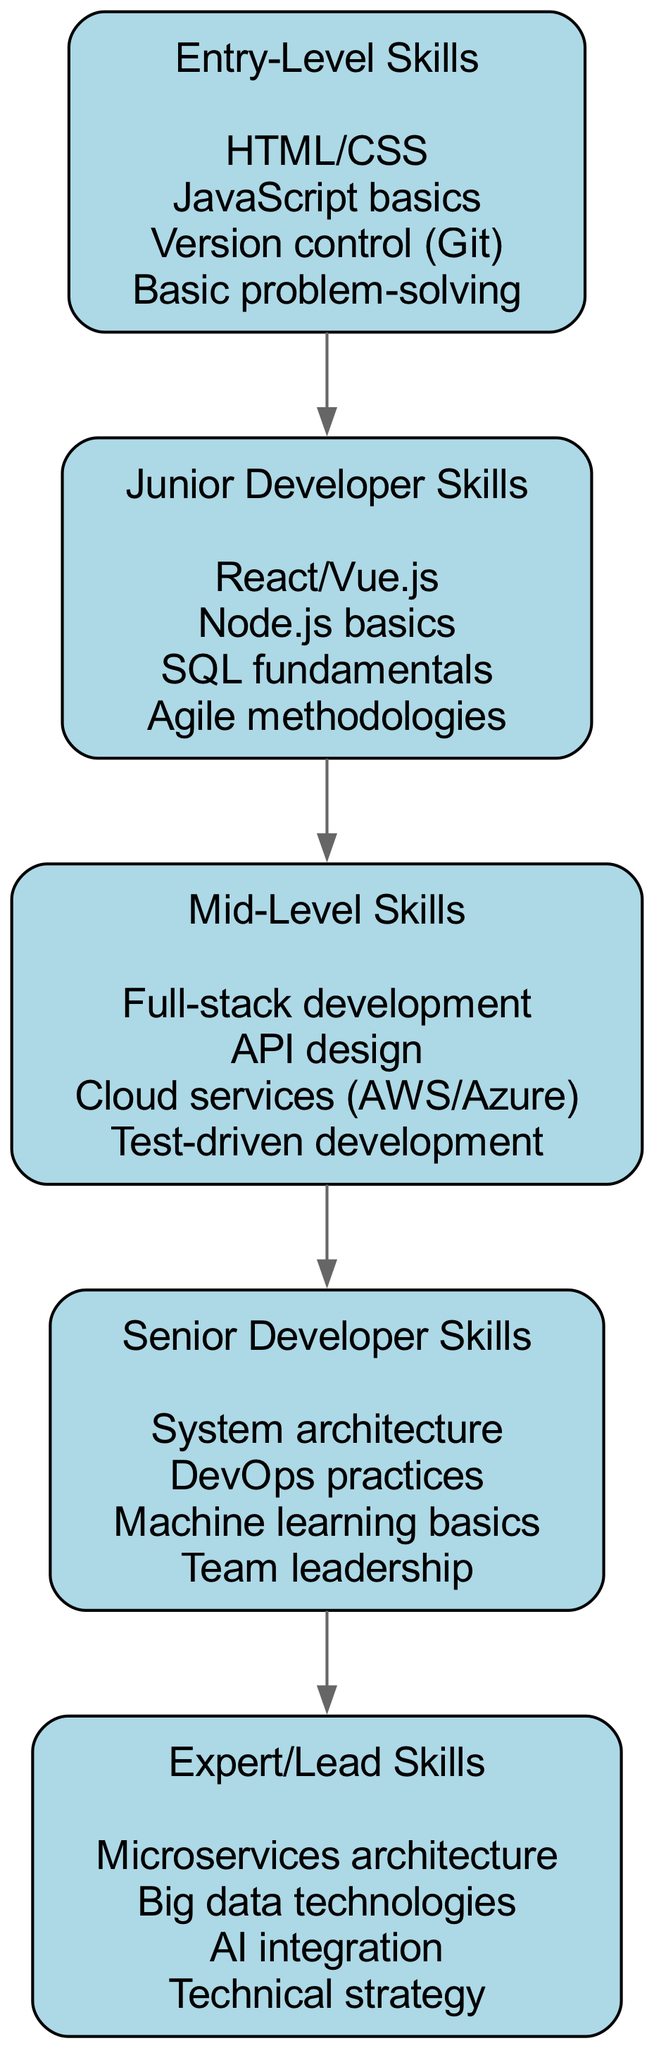What are the skills listed under Entry-Level? The Entry-Level Skills node specifies four items, which are directly displayed below the node label in the diagram. These items are HTML/CSS, JavaScript basics, Version control (Git), and Basic problem-solving.
Answer: HTML/CSS, JavaScript basics, Version control (Git), Basic problem-solving How many nodes are there in the diagram? Each skill level is represented by a unique node, and the diagram lists five levels: Entry-Level Skills, Junior Developer Skills, Mid-Level Skills, Senior Developer Skills, and Expert/Lead Skills. Counting these, we see that there are a total of five nodes.
Answer: 5 What is the relationship between Junior Developer Skills and Mid-Level Skills? In the diagram, the arrow connecting Junior Developer Skills directly to Mid-Level Skills indicates that there is a progression from junior to mid-level skills, reflecting an upward flow in the hierarchy.
Answer: progressive relationship Which skills are categorized as Expert/Lead Skills? The Expert/Lead Skills node lists four items, which are shown as belonging to that specific level in the diagram. They are Microservices architecture, Big data technologies, AI integration, and Technical strategy.
Answer: Microservices architecture, Big data technologies, AI integration, Technical strategy What is the relationship flow from Entry-Level to Expert/Lead Skills? To find the relationship flow, we need to start at Entry-Level Skills and trace the arrows upward through Junior Developer Skills, then Mid-Level Skills, followed by Senior Developer Skills, until we reach Expert/Lead Skills. This demonstrates a linear progression through the levels.
Answer: linear progression through the levels What is the first skill listed under Mid-Level Skills? Within the Mid-Level Skills node, the first item listed is Full-stack development, as the items are arranged in a specific order in the diagram. This is the topmost item seen when observing the node.
Answer: Full-stack development How many skills are listed in total across all levels? To find the total number of skills, we count the items within each node: 4 in Entry-Level, 4 in Junior Developer, 4 in Mid-Level, 4 in Senior Developer, and 4 in Expert/Lead. Adding these together gives a total of 20 skills across all levels.
Answer: 20 